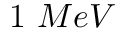<formula> <loc_0><loc_0><loc_500><loc_500>1 \ M e V</formula> 